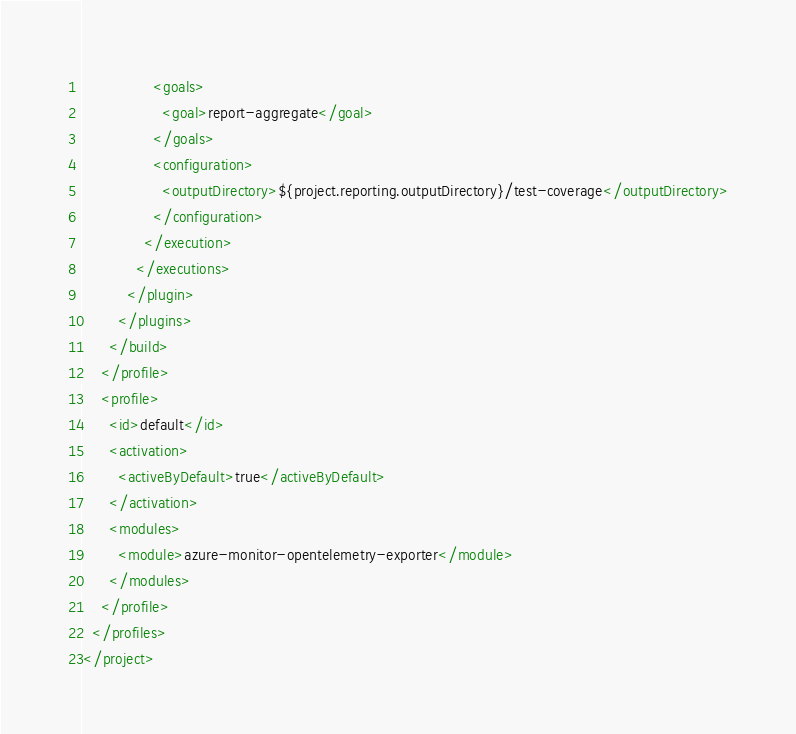Convert code to text. <code><loc_0><loc_0><loc_500><loc_500><_XML_>                <goals>
                  <goal>report-aggregate</goal>
                </goals>
                <configuration>
                  <outputDirectory>${project.reporting.outputDirectory}/test-coverage</outputDirectory>
                </configuration>
              </execution>
            </executions>
          </plugin>
        </plugins>
      </build>
    </profile>
    <profile>
      <id>default</id>
      <activation>
        <activeByDefault>true</activeByDefault>
      </activation>
      <modules>
        <module>azure-monitor-opentelemetry-exporter</module>
      </modules>
    </profile>
  </profiles>
</project>
</code> 